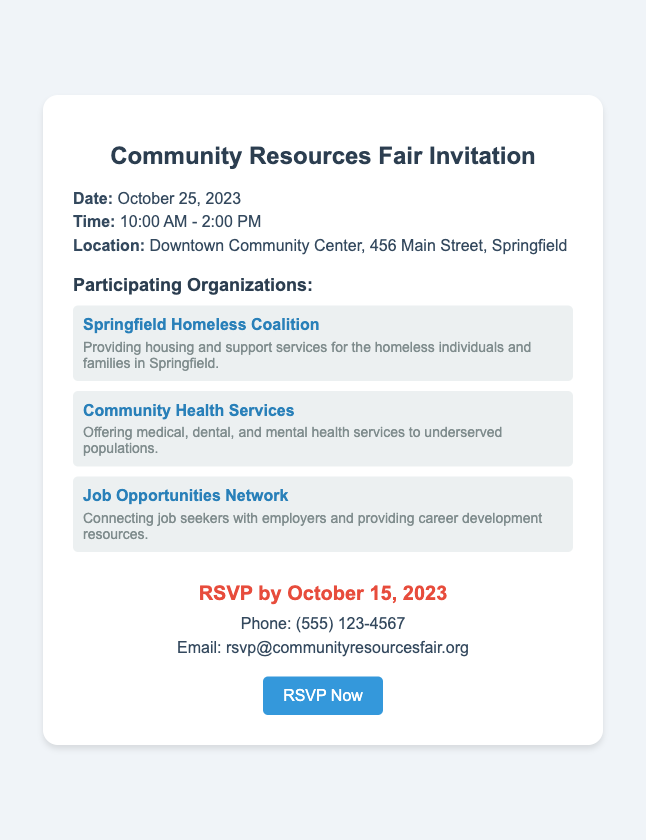What is the date of the event? The date of the event is specifically mentioned in the document.
Answer: October 25, 2023 What is the time duration of the fair? The time during which the fair takes place is stated in the document.
Answer: 10:00 AM - 2:00 PM Where is the Community Resources Fair held? The location of the fair is clearly stated in the document.
Answer: Downtown Community Center, 456 Main Street, Springfield Which organization focuses on housing and support services? This organization is mentioned in the document as providing specific services related to homelessness.
Answer: Springfield Homeless Coalition When is the RSVP deadline? The document specifies the last date for RSVPs.
Answer: October 15, 2023 What is the contact number for RSVPs? The phone number provided for RSVPs can be found in the document.
Answer: (555) 123-4567 How many organizations are listed in the document? The document includes a section with multiple organizations, and this question asks for the total count.
Answer: Three What type of services does Community Health Services provide? The document describes the kind of services offered by this organization.
Answer: Medical, dental, and mental health services What is the main purpose of the Job Opportunities Network? The document gives a brief description of the network's function.
Answer: Connecting job seekers with employers 